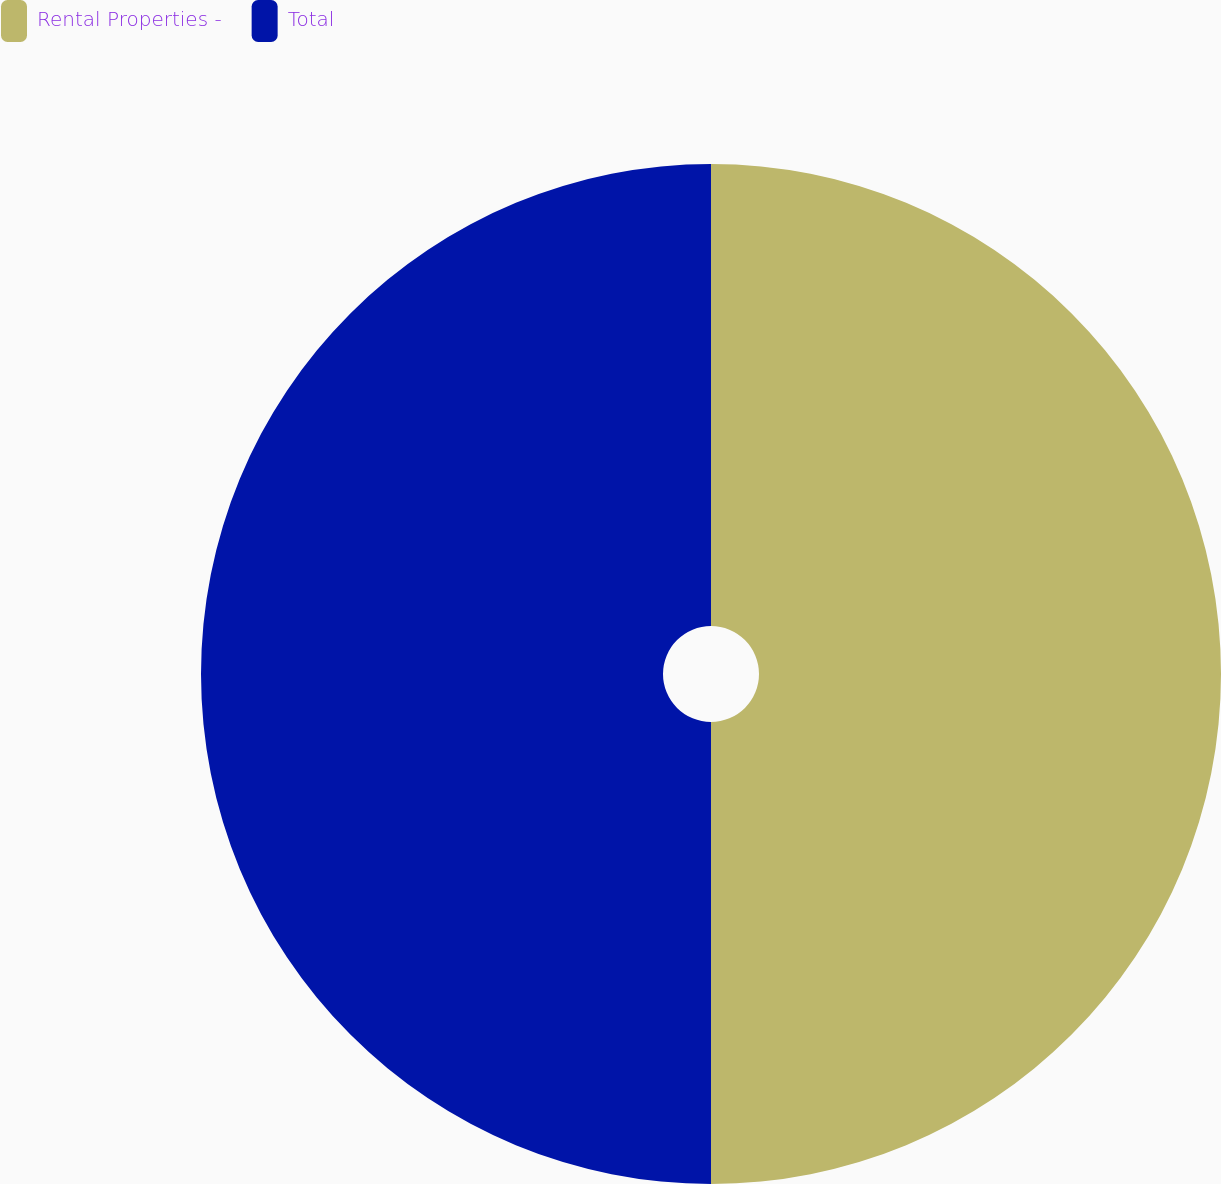Convert chart. <chart><loc_0><loc_0><loc_500><loc_500><pie_chart><fcel>Rental Properties -<fcel>Total<nl><fcel>50.0%<fcel>50.0%<nl></chart> 